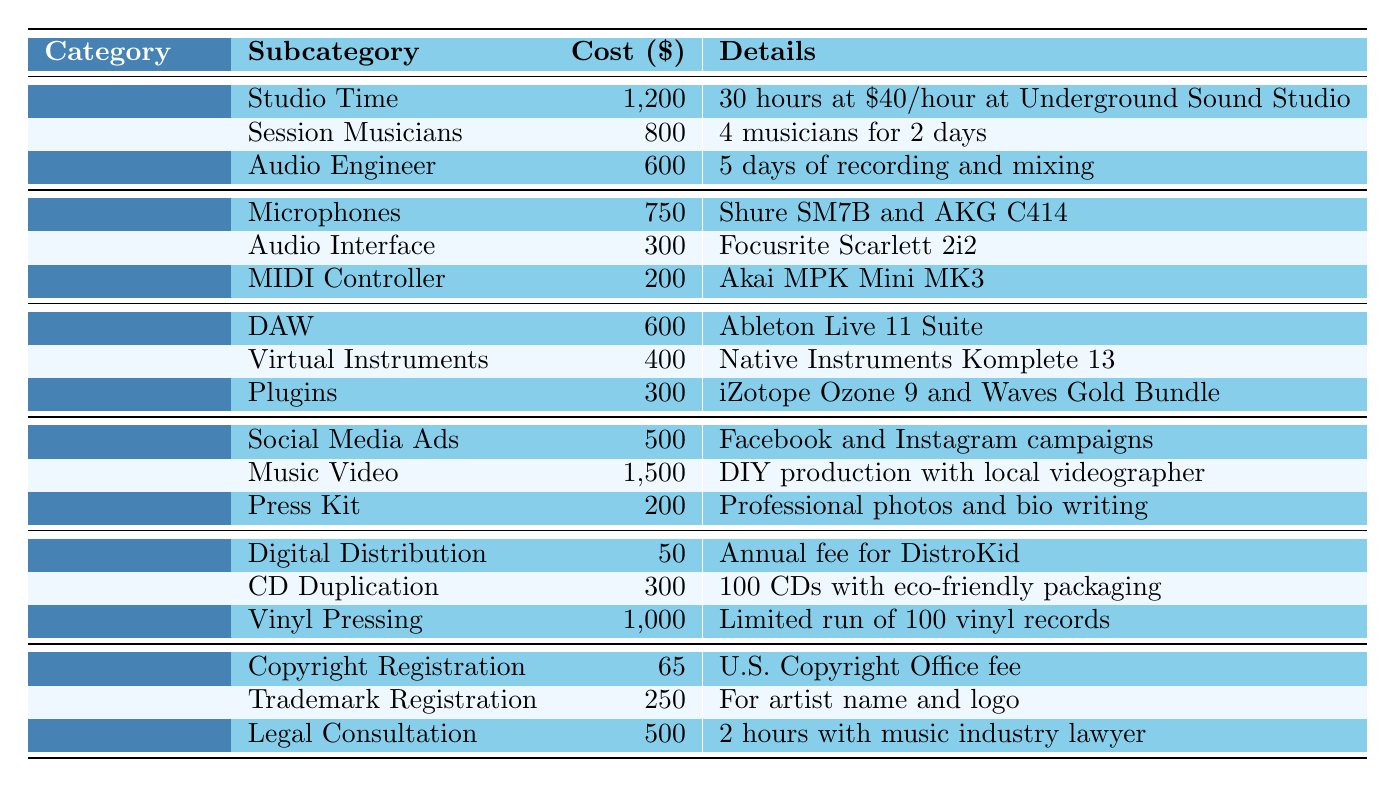What is the total cost for the "Recording" category? The costs for the "Recording" category are Studio Time ($1,200), Session Musicians ($800), and Audio Engineer ($600). Adding these together gives us 1,200 + 800 + 600 = 2,600.
Answer: 2,600 Which subcategory has the highest cost in the "Marketing" category? In the "Marketing" category, the costs are Social Media Ads ($500), Music Video ($1,500), and Press Kit ($200). The highest cost is $1,500 for the Music Video.
Answer: Music Video Is the cost of "CD Duplication" greater than the cost of "Digital Distribution"? The cost of CD Duplication is $300, and the cost of Digital Distribution is $50. Since 300 is greater than 50, the answer is yes.
Answer: Yes What is the average cost of the "Equipment" category? The costs for the "Equipment" category are Microphones ($750), Audio Interface ($300), and MIDI Controller ($200). Their total is 750 + 300 + 200 = 1,250. There are 3 subcategories, so the average is 1,250 / 3 = approximately 416.67.
Answer: 416.67 Which legal expense has the lowest cost? The legal expenses are Copyright Registration ($65), Trademark Registration ($250), and Legal Consultation ($500). The lowest is $65 for Copyright Registration.
Answer: Copyright Registration What is the total cost for all categories? The total costs for each category are: Recording ($2,600), Equipment ($1,250), Software ($1,300), Marketing ($2,200), Distribution ($1,350), and Legal ($815). Summing these values gives us 2,600 + 1,250 + 1,300 + 2,200 + 1,350 + 815 = 9,515.
Answer: 9,515 Is the cost of "Session Musicians" more than the combined cost of "Plugins" and "Digital Distribution"? The cost of Session Musicians is $800. The combined cost of Plugins ($300) and Digital Distribution ($50) is 300 + 50 = 350. Since 800 is greater than 350, the answer is yes.
Answer: Yes How much more does "Vinyl Pressing" cost compared to "Copyright Registration"? Vinyl Pressing costs $1,000 and Copyright Registration costs $65. To find the difference, we calculate 1,000 - 65 = 935.
Answer: 935 What percentage of the total music production costs does the "Audio Interface" expense represent? The cost of the Audio Interface is $300. The total production costs are $9,515. The percentage is (300 / 9,515) * 100, which is approximately 3.15%.
Answer: 3.15% What is the total amount spent on "Software"? The costs for Software are DAW ($600), Virtual Instruments ($400), and Plugins ($300). Adding these up gives 600 + 400 + 300 = 1,300.
Answer: 1,300 